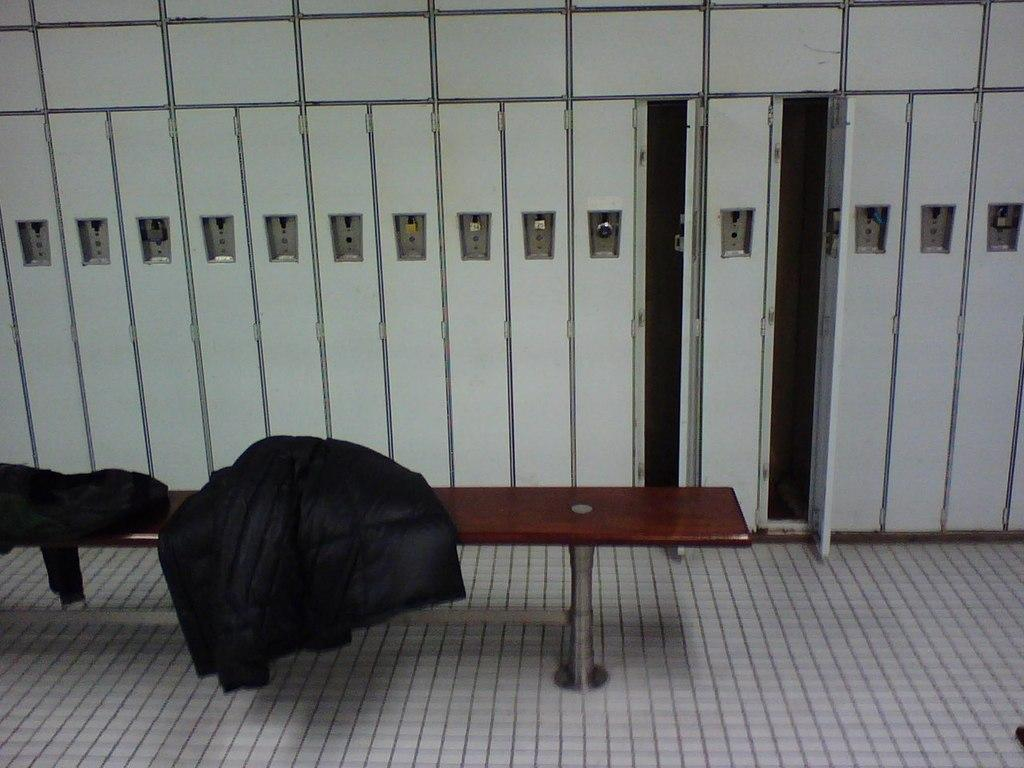What is placed on the floor in the image? There is a bench on the floor in the image. What is placed on the bench? There are jackets on the bench. What can be seen in the background of the image? There are cupboards in the background of the image. How many yams are on the bench in the image? There are no yams present in the image; only jackets are placed on the bench. 